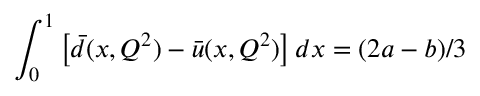<formula> <loc_0><loc_0><loc_500><loc_500>\int _ { 0 } ^ { 1 } \left [ \bar { d } ( x , Q ^ { 2 } ) - \bar { u } ( x , Q ^ { 2 } ) \right ] d x = ( 2 a - b ) / 3</formula> 